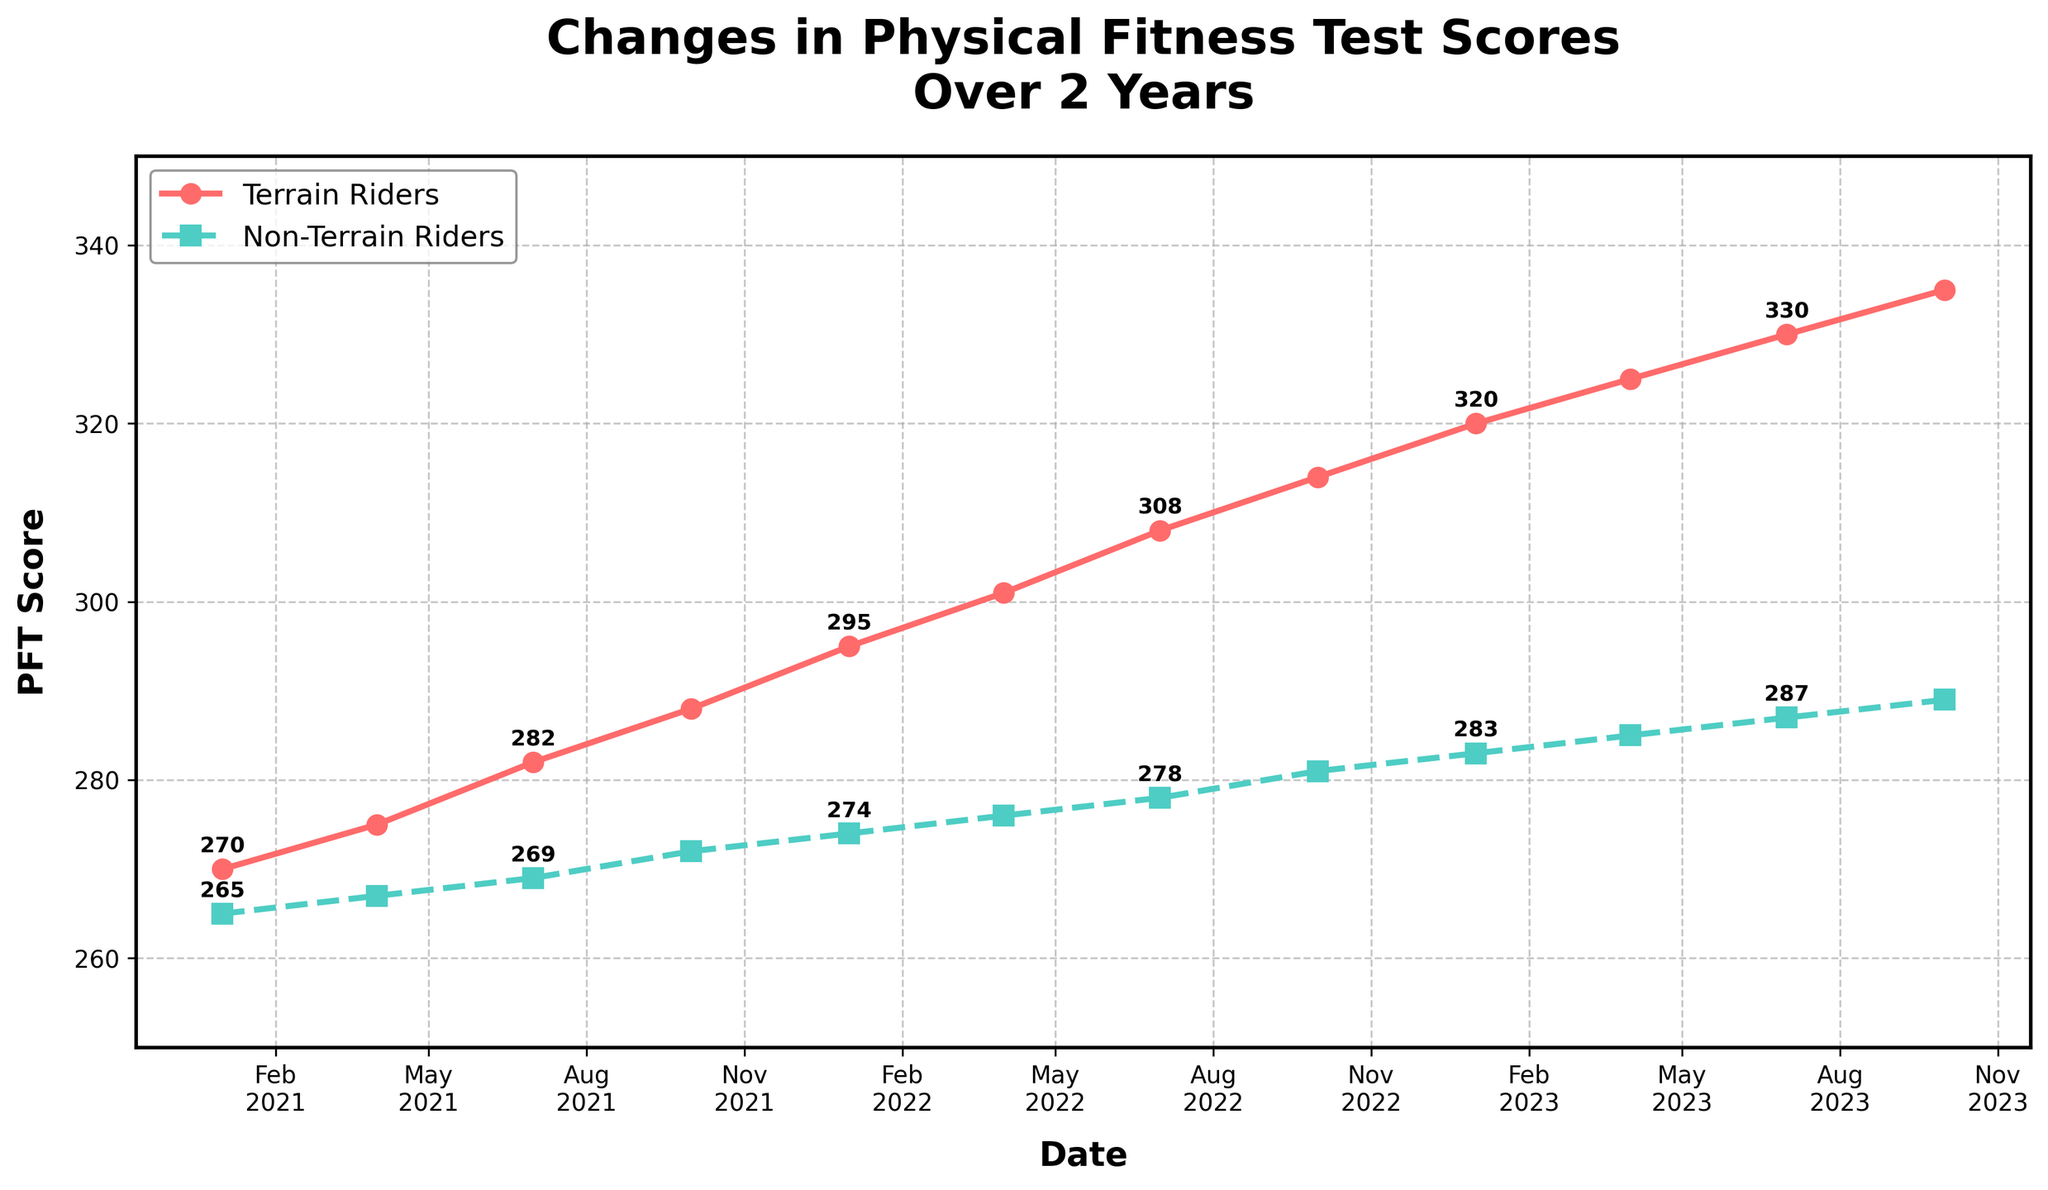What is the overall trend in PFT scores for Terrain Riders over the 2-year period? The PFT scores for Terrain Riders show a consistent increase from January 2021 to October 2023. Starting at 270 in January 2021 and rising steadily each quarter, reaching 335 by October 2023.
Answer: Increasing trend How does the change in PFT scores from January 2021 to October 2023 for Terrain Riders compare to Non-Terrain Riders? The PFT scores for Terrain Riders increased from 270 to 335, an increase of 65 points over the 2 years. For Non-Terrain Riders, the scores increased from 265 to 289, an increase of 24 points over the same period. Thus, Terrain Riders had a larger increase in PFT scores.
Answer: Terrain Riders had a larger increase At which points on the timeline do both groups have the closest PFT scores? The closest PFT scores for both groups occur in January 2021, with Terrain Riders scoring 270 and Non-Terrain Riders scoring 265, resulting in a 5-point difference.
Answer: January 2021 What is the average PFT score for Terrain Riders in the first year? The scores for the first year (2021) are: 270 (Jan), 275 (Apr), 282 (Jul), and 288 (Oct). The average is calculated by summing these values and dividing by 4: (270 + 275 + 282 + 288) / 4 = 278.75.
Answer: 278.75 By how many points did the Non-Terrain Riders' PFT scores increase from April 2022 to October 2023? In April 2022, the Non-Terrain Riders' score was 276. By October 2023, it was 289. The increase is 289 - 276 = 13 points.
Answer: 13 points Are the increases in PFT scores for both groups consistent each quarter? Both groups show a consistent increase in their PFT scores every quarter. For Terrain Riders, the rise is steady from 270 to 335 over the period. Non-Terrain Riders also have a steady but smaller increase from 265 to 289.
Answer: Yes, consistent Which group had a higher PFT score in April 2022 and by how much? In April 2022, Terrain Riders scored 301 and Non-Terrain Riders scored 276. The difference is 301 - 276 = 25 points.
Answer: Terrain Riders, by 25 points What is the rate of increase in PFT scores for Terrain Riders from January 2021 to July 2021? The increase is from 270 in January to 282 in July. The time span is 6 months. The rate of increase is (282 - 270) / 6 = 2 points per month.
Answer: 2 points per month Which month shows the largest difference in PFT scores between Terrain and Non-Terrain Riders? In October 2023, Terrain Riders scored 335 and Non-Terrain Riders scored 289. The difference is 335 - 289 = 46 points, the largest difference observed.
Answer: October 2023 What is the total increase in PFT scores for both groups combined over 2 years? Terrain Riders increased from 270 to 335, a 65-point increase. Non-Terrain Riders increased from 265 to 289, a 24-point increase. The total increase for both groups combined is 65 + 24 = 89 points.
Answer: 89 points 